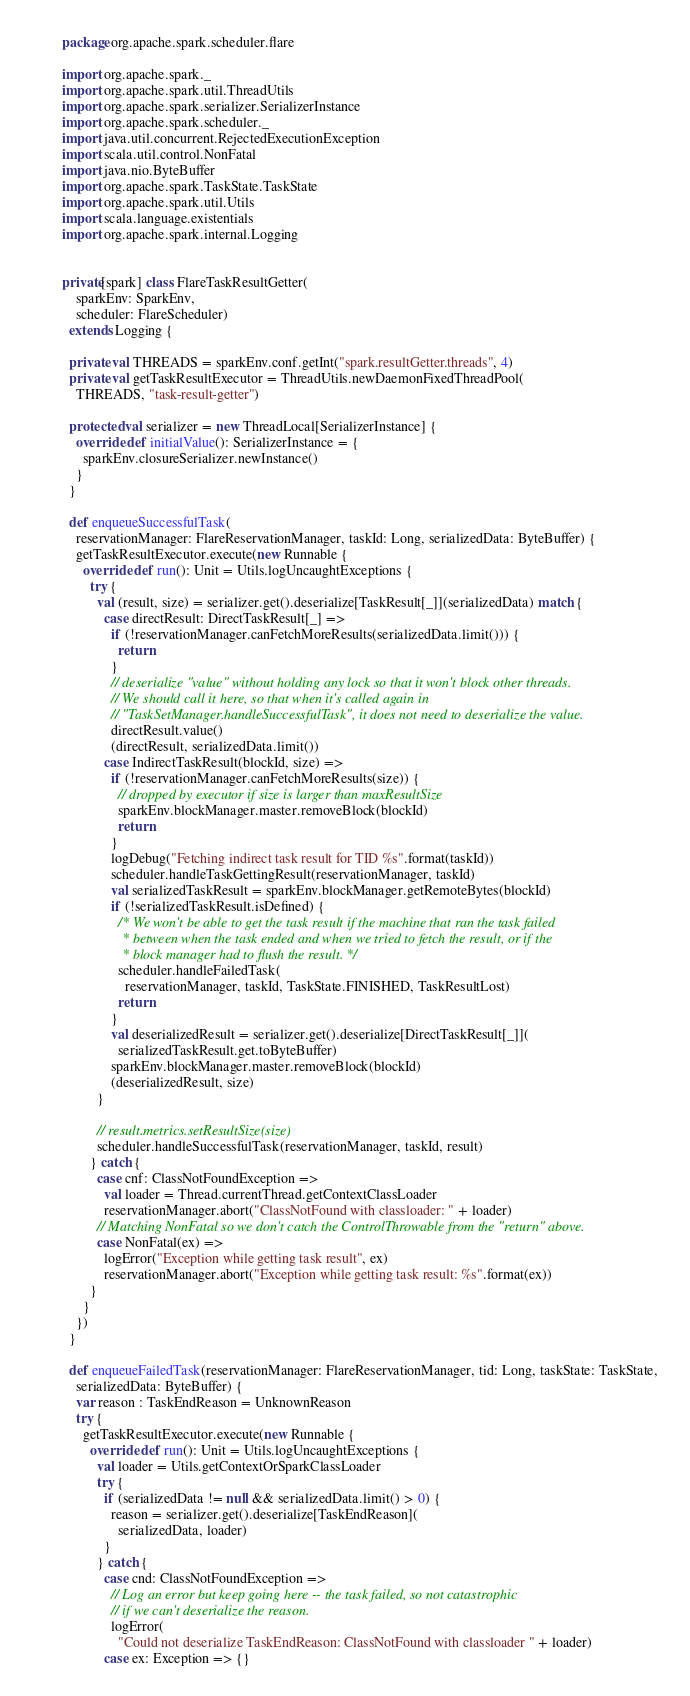Convert code to text. <code><loc_0><loc_0><loc_500><loc_500><_Scala_>package org.apache.spark.scheduler.flare

import org.apache.spark._
import org.apache.spark.util.ThreadUtils
import org.apache.spark.serializer.SerializerInstance
import org.apache.spark.scheduler._
import java.util.concurrent.RejectedExecutionException
import scala.util.control.NonFatal
import java.nio.ByteBuffer
import org.apache.spark.TaskState.TaskState
import org.apache.spark.util.Utils
import scala.language.existentials
import org.apache.spark.internal.Logging


private[spark] class FlareTaskResultGetter(
    sparkEnv: SparkEnv, 
    scheduler: FlareScheduler) 
  extends Logging {
  
  private val THREADS = sparkEnv.conf.getInt("spark.resultGetter.threads", 4)
  private val getTaskResultExecutor = ThreadUtils.newDaemonFixedThreadPool(
    THREADS, "task-result-getter")
  
  protected val serializer = new ThreadLocal[SerializerInstance] {
    override def initialValue(): SerializerInstance = {
      sparkEnv.closureSerializer.newInstance()
    }
  }
  
  def enqueueSuccessfulTask(
    reservationManager: FlareReservationManager, taskId: Long, serializedData: ByteBuffer) {
    getTaskResultExecutor.execute(new Runnable {
      override def run(): Unit = Utils.logUncaughtExceptions {
        try {
          val (result, size) = serializer.get().deserialize[TaskResult[_]](serializedData) match {
            case directResult: DirectTaskResult[_] =>
              if (!reservationManager.canFetchMoreResults(serializedData.limit())) {
                return
              }
              // deserialize "value" without holding any lock so that it won't block other threads.
              // We should call it here, so that when it's called again in
              // "TaskSetManager.handleSuccessfulTask", it does not need to deserialize the value.
              directResult.value()
              (directResult, serializedData.limit())
            case IndirectTaskResult(blockId, size) =>
              if (!reservationManager.canFetchMoreResults(size)) {
                // dropped by executor if size is larger than maxResultSize
                sparkEnv.blockManager.master.removeBlock(blockId)
                return
              }
              logDebug("Fetching indirect task result for TID %s".format(taskId))
              scheduler.handleTaskGettingResult(reservationManager, taskId)
              val serializedTaskResult = sparkEnv.blockManager.getRemoteBytes(blockId)
              if (!serializedTaskResult.isDefined) {
                /* We won't be able to get the task result if the machine that ran the task failed
                 * between when the task ended and when we tried to fetch the result, or if the
                 * block manager had to flush the result. */
                scheduler.handleFailedTask(
                  reservationManager, taskId, TaskState.FINISHED, TaskResultLost)
                return
              }
              val deserializedResult = serializer.get().deserialize[DirectTaskResult[_]](
                serializedTaskResult.get.toByteBuffer)
              sparkEnv.blockManager.master.removeBlock(blockId)
              (deserializedResult, size)
          }

          // result.metrics.setResultSize(size)
          scheduler.handleSuccessfulTask(reservationManager, taskId, result)
        } catch {
          case cnf: ClassNotFoundException =>
            val loader = Thread.currentThread.getContextClassLoader
            reservationManager.abort("ClassNotFound with classloader: " + loader)
          // Matching NonFatal so we don't catch the ControlThrowable from the "return" above.
          case NonFatal(ex) =>
            logError("Exception while getting task result", ex)
            reservationManager.abort("Exception while getting task result: %s".format(ex))
        }
      }
    })
  }

  def enqueueFailedTask(reservationManager: FlareReservationManager, tid: Long, taskState: TaskState,
    serializedData: ByteBuffer) {
    var reason : TaskEndReason = UnknownReason
    try {
      getTaskResultExecutor.execute(new Runnable {
        override def run(): Unit = Utils.logUncaughtExceptions {
          val loader = Utils.getContextOrSparkClassLoader
          try {
            if (serializedData != null && serializedData.limit() > 0) {
              reason = serializer.get().deserialize[TaskEndReason](
                serializedData, loader)
            }
          } catch {
            case cnd: ClassNotFoundException =>
              // Log an error but keep going here -- the task failed, so not catastrophic
              // if we can't deserialize the reason.
              logError(
                "Could not deserialize TaskEndReason: ClassNotFound with classloader " + loader)
            case ex: Exception => {}</code> 